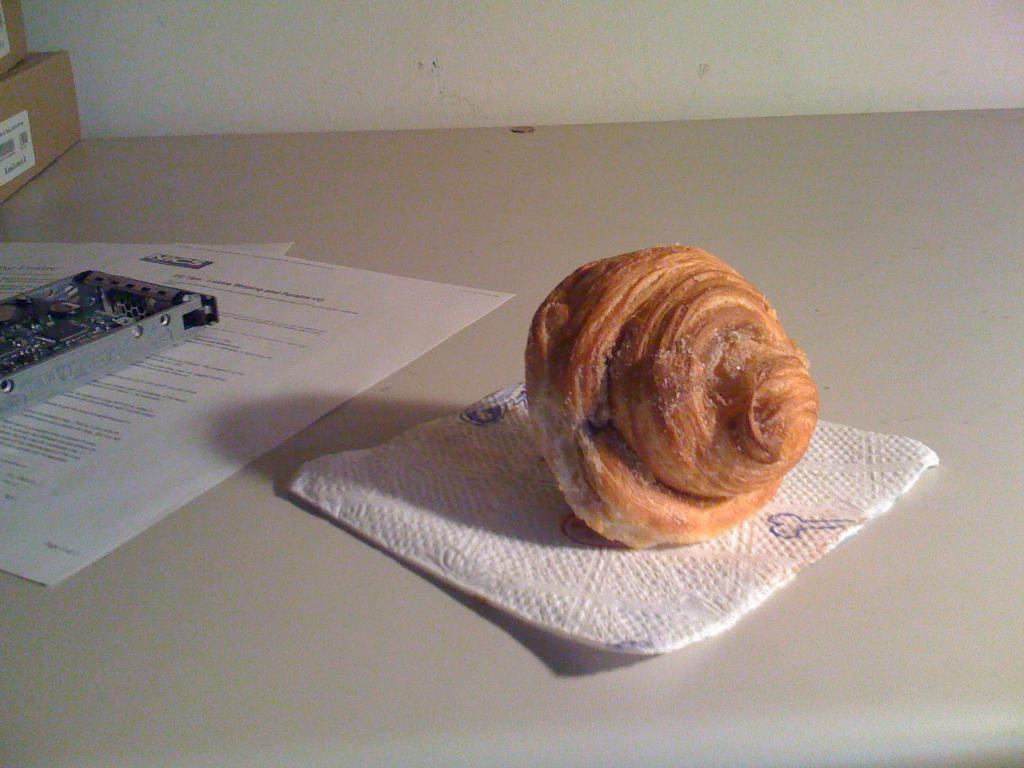What piece of furniture is present in the image? There is a table in the image. What is on top of the table? There is a food item, papers, two card boxes, and a metal object on the table. Can you describe the wall in the image? There is a wall in the image, but no specific details about the wall are provided. How many card boxes are on the table? There are two card boxes on the table. How many bears are playing with a ball on the table in the image? There are no bears or balls present in the image. 